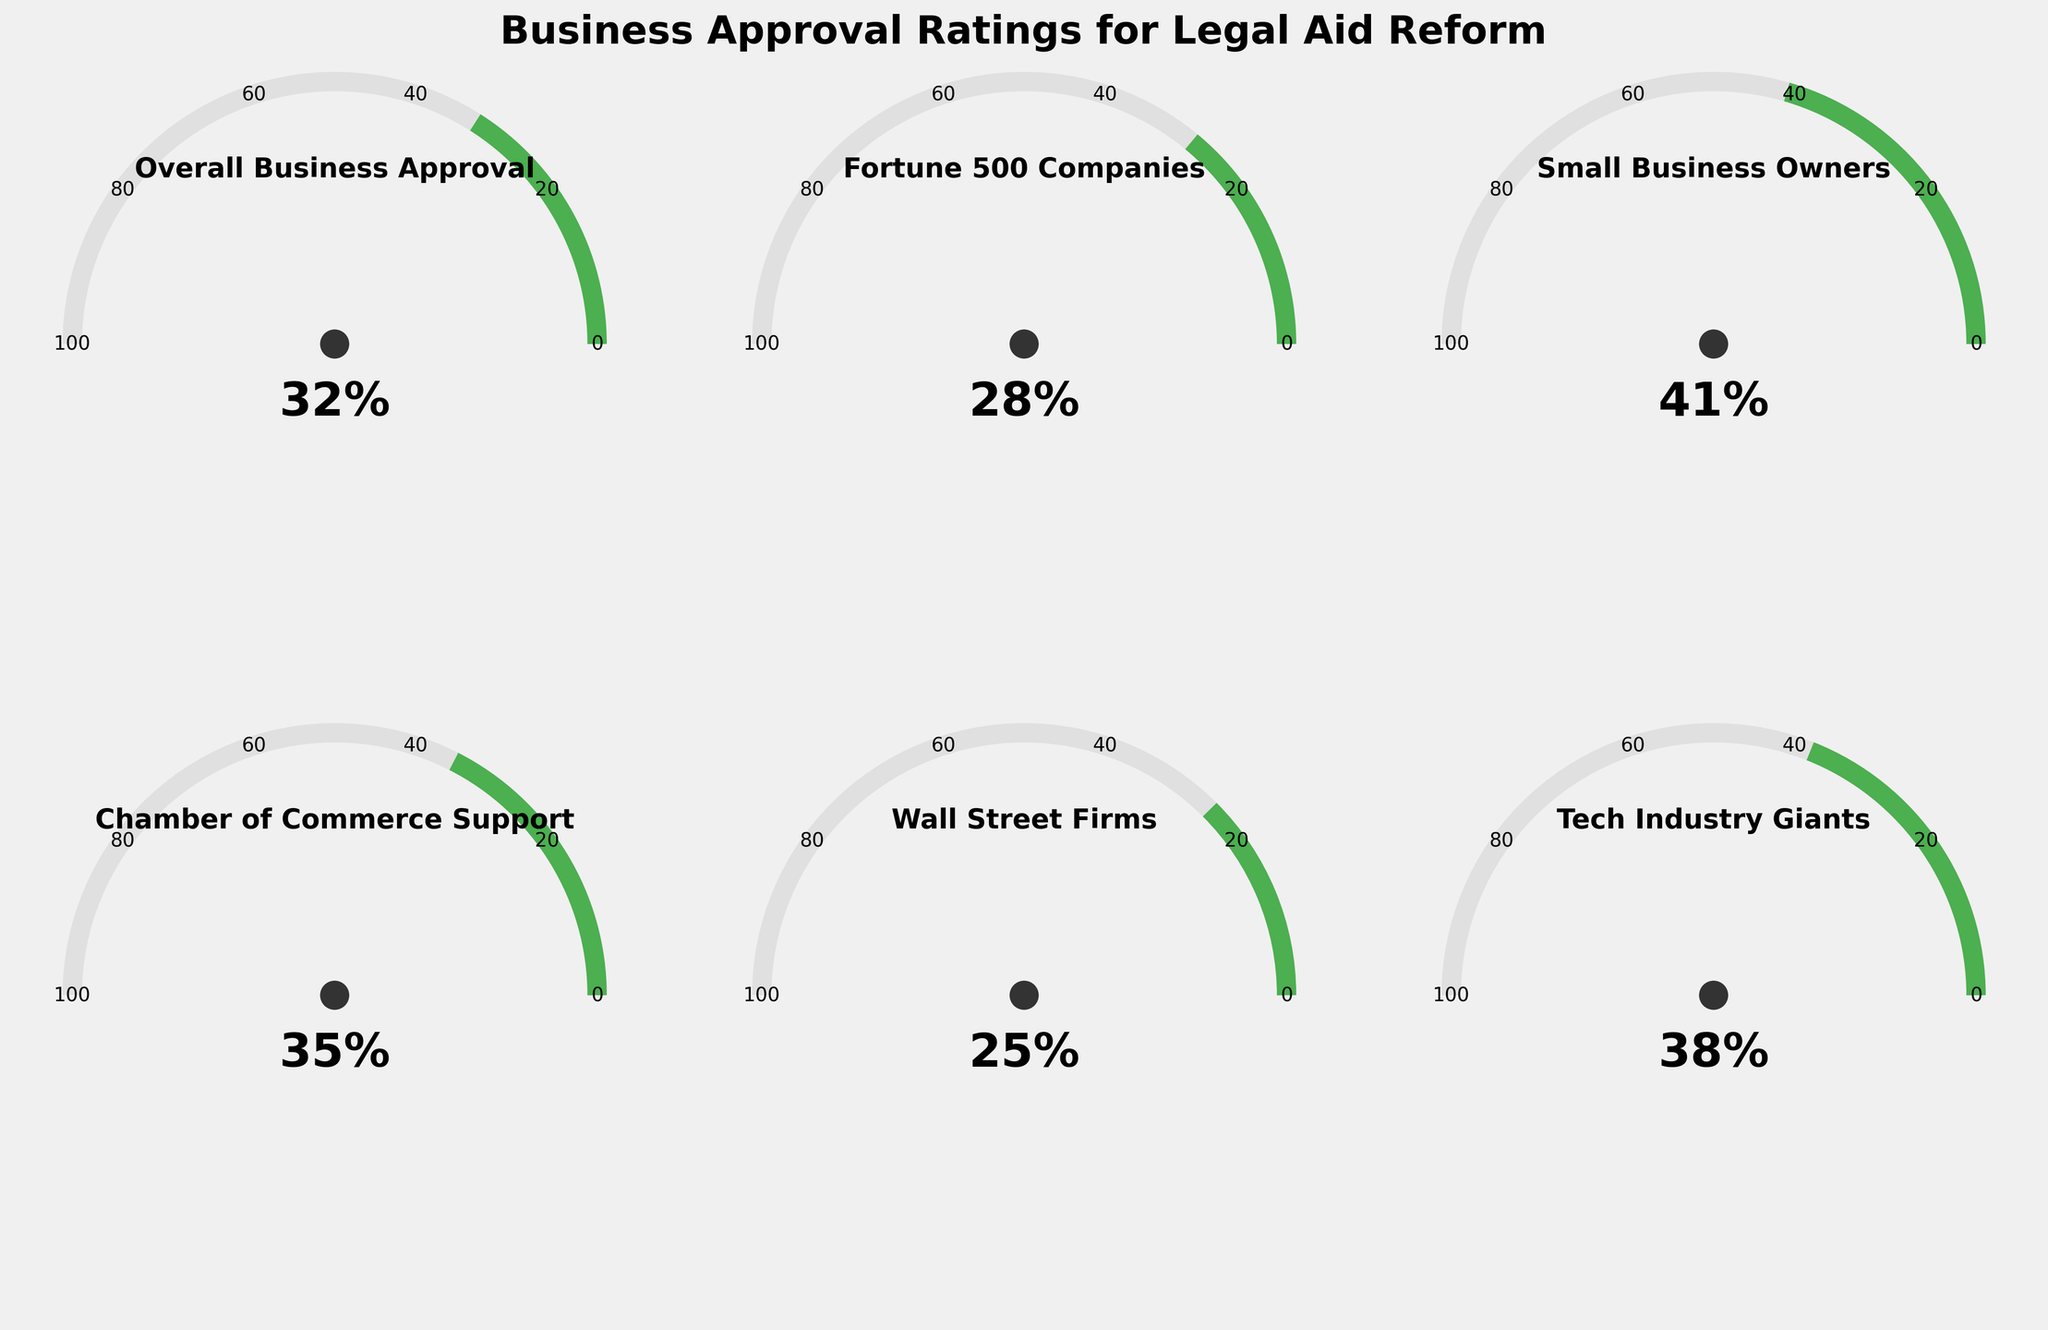What is the overall business approval rating for the proposed legal aid reform? The Overall Business Approval gauge shows a 32% approval rating in the chart
Answer: 32% Which business group has the highest approval rating for the proposed legal aid reform? By comparing all gauge titles and their percentages, Small Business Owners have the highest approval rating with 41%
Answer: Small Business Owners How much higher is the approval rating of Small Business Owners compared to Wall Street Firms? Small Business Owners have a rating of 41% and Wall Street Firms have 25%. The difference is 41% - 25% = 16%
Answer: 16% What is the minimum approval rating shown in the gauge charts? The minimum value across all the gauges is 0% as indicated in the arcs
Answer: 0% What is the approval rating for Fortune 500 Companies? The Fortune 500 Companies gauge shows a 28% approval rating in the chart
Answer: 28% Which business group has the lowest approval rating for the proposed legal aid reform? By comparing the approval percentages, Wall Street Firms have the lowest rating at 25%
Answer: Wall Street Firms What is the combined approval rating of Tech Industry Giants and Chamber of Commerce Support? Tech Industry Giants have 38% and Chamber of Commerce Support has 35%. The combined rating is 38% + 35% = 73%
Answer: 73% Is the approval rating of Chamber of Commerce Support higher than the overall business approval rating? Chamber of Commerce Support has a 35% approval, which is higher than the Overall Business Approval of 32%
Answer: Yes, it is higher What is the average approval rating across all business groups shown? Summing the ratings: 32% + 28% + 41% + 35% + 25% + 38% = 199%. Dividing by the number of groups (6) gives the average: 199% / 6 ≈ 33.17%
Answer: 33.17% How does the approval rating of Tech Industry Giants compare to that of Fortune 500 Companies? Tech Industry Giants have a 38% approval while Fortune 500 Companies have 28%, thus Tech Industry Giants have a higher rating
Answer: Tech Industry Giants have a higher rating 